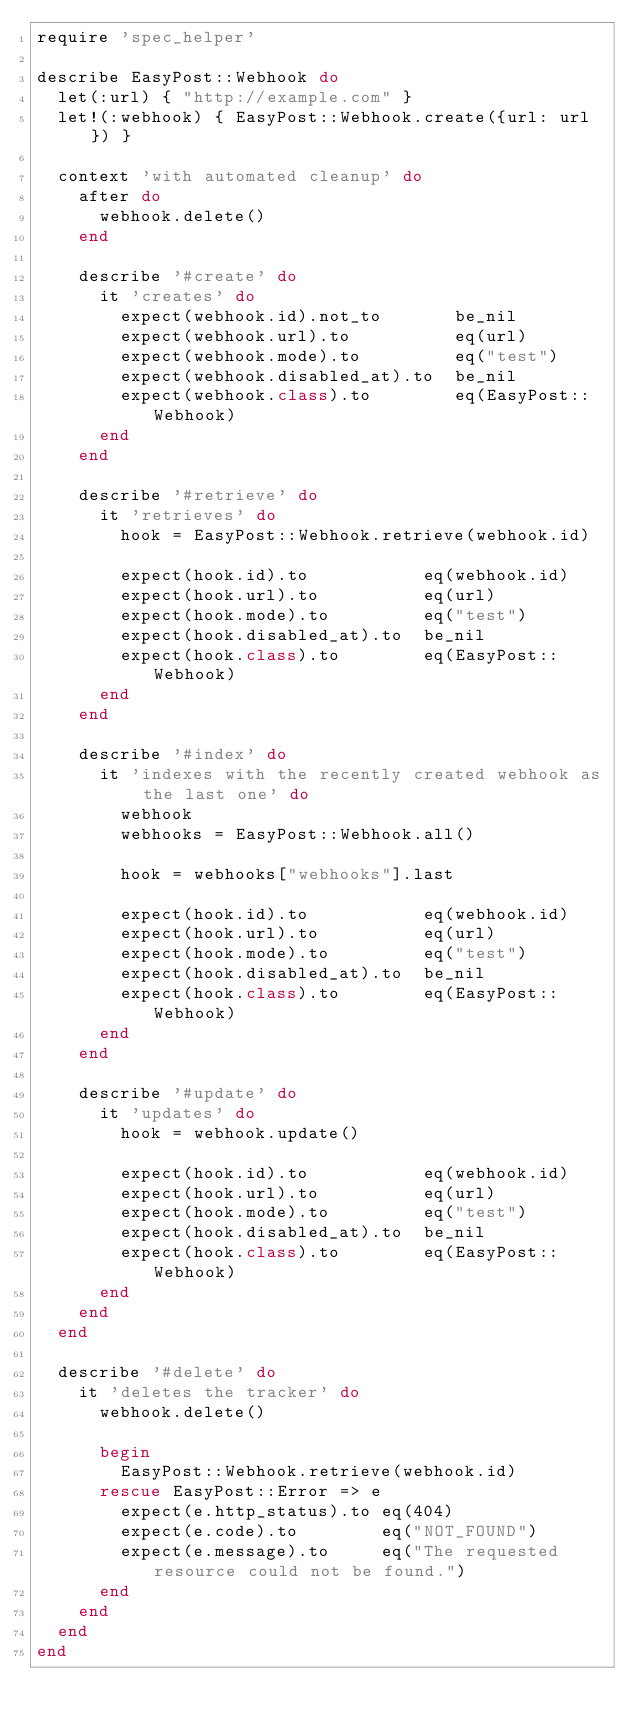Convert code to text. <code><loc_0><loc_0><loc_500><loc_500><_Ruby_>require 'spec_helper'

describe EasyPost::Webhook do
  let(:url) { "http://example.com" }
  let!(:webhook) { EasyPost::Webhook.create({url: url}) }

  context 'with automated cleanup' do
    after do
      webhook.delete()
    end

    describe '#create' do
      it 'creates' do
        expect(webhook.id).not_to       be_nil
        expect(webhook.url).to          eq(url)
        expect(webhook.mode).to         eq("test")
        expect(webhook.disabled_at).to  be_nil
        expect(webhook.class).to        eq(EasyPost::Webhook)
      end
    end

    describe '#retrieve' do
      it 'retrieves' do
        hook = EasyPost::Webhook.retrieve(webhook.id)

        expect(hook.id).to           eq(webhook.id)
        expect(hook.url).to          eq(url)
        expect(hook.mode).to         eq("test")
        expect(hook.disabled_at).to  be_nil
        expect(hook.class).to        eq(EasyPost::Webhook)
      end
    end

    describe '#index' do
      it 'indexes with the recently created webhook as the last one' do
        webhook
        webhooks = EasyPost::Webhook.all()

        hook = webhooks["webhooks"].last

        expect(hook.id).to           eq(webhook.id)
        expect(hook.url).to          eq(url)
        expect(hook.mode).to         eq("test")
        expect(hook.disabled_at).to  be_nil
        expect(hook.class).to        eq(EasyPost::Webhook)
      end
    end

    describe '#update' do
      it 'updates' do
        hook = webhook.update()

        expect(hook.id).to           eq(webhook.id)
        expect(hook.url).to          eq(url)
        expect(hook.mode).to         eq("test")
        expect(hook.disabled_at).to  be_nil
        expect(hook.class).to        eq(EasyPost::Webhook)
      end
    end
  end

  describe '#delete' do
    it 'deletes the tracker' do
      webhook.delete()

      begin
        EasyPost::Webhook.retrieve(webhook.id)
      rescue EasyPost::Error => e
        expect(e.http_status).to eq(404)
        expect(e.code).to        eq("NOT_FOUND")
        expect(e.message).to     eq("The requested resource could not be found.")
      end
    end
  end
end
</code> 